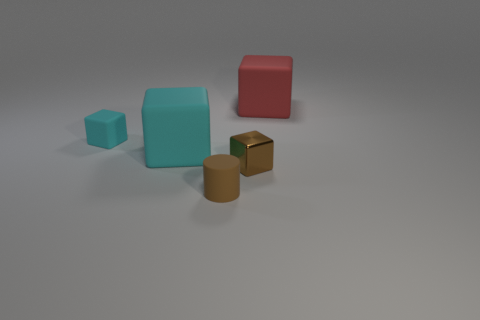Add 1 metallic blocks. How many objects exist? 6 Subtract all cylinders. How many objects are left? 4 Subtract all cyan things. Subtract all tiny brown things. How many objects are left? 1 Add 3 small matte cylinders. How many small matte cylinders are left? 4 Add 2 brown cubes. How many brown cubes exist? 3 Subtract 0 gray balls. How many objects are left? 5 